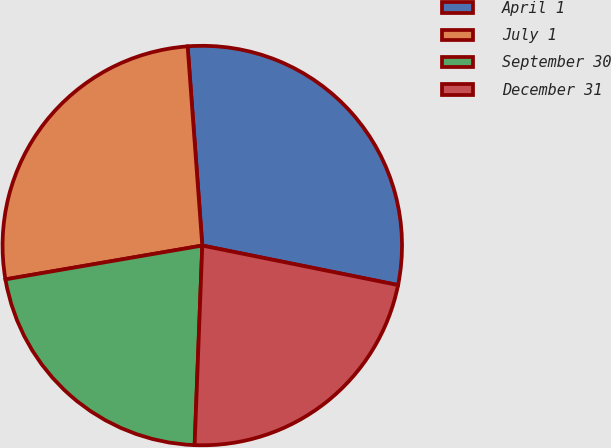Convert chart. <chart><loc_0><loc_0><loc_500><loc_500><pie_chart><fcel>April 1<fcel>July 1<fcel>September 30<fcel>December 31<nl><fcel>29.34%<fcel>26.54%<fcel>21.68%<fcel>22.44%<nl></chart> 